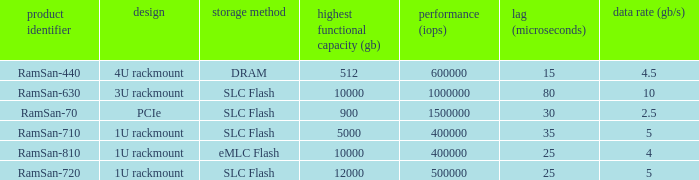What are the range distortion values for the ramsan-630? 3U rackmount. 